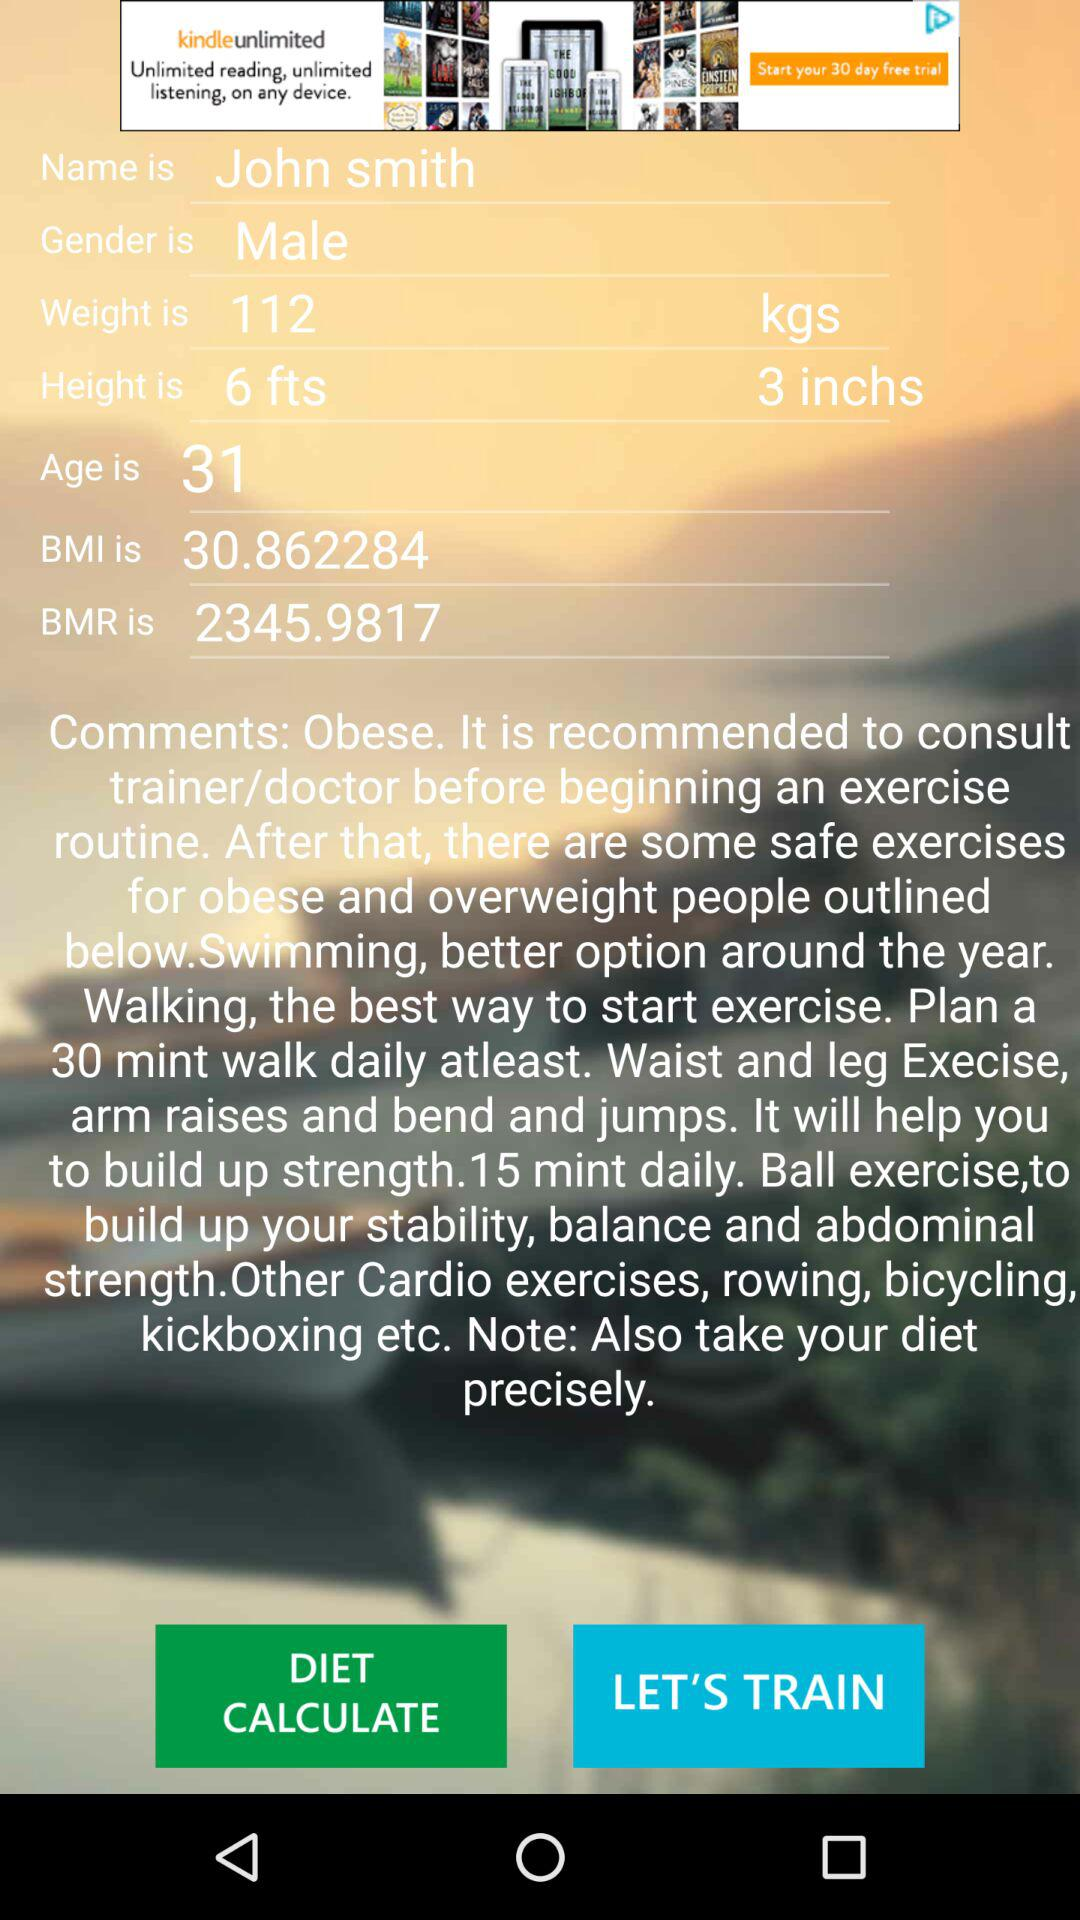What is the weight? The weight is 112 kg. 